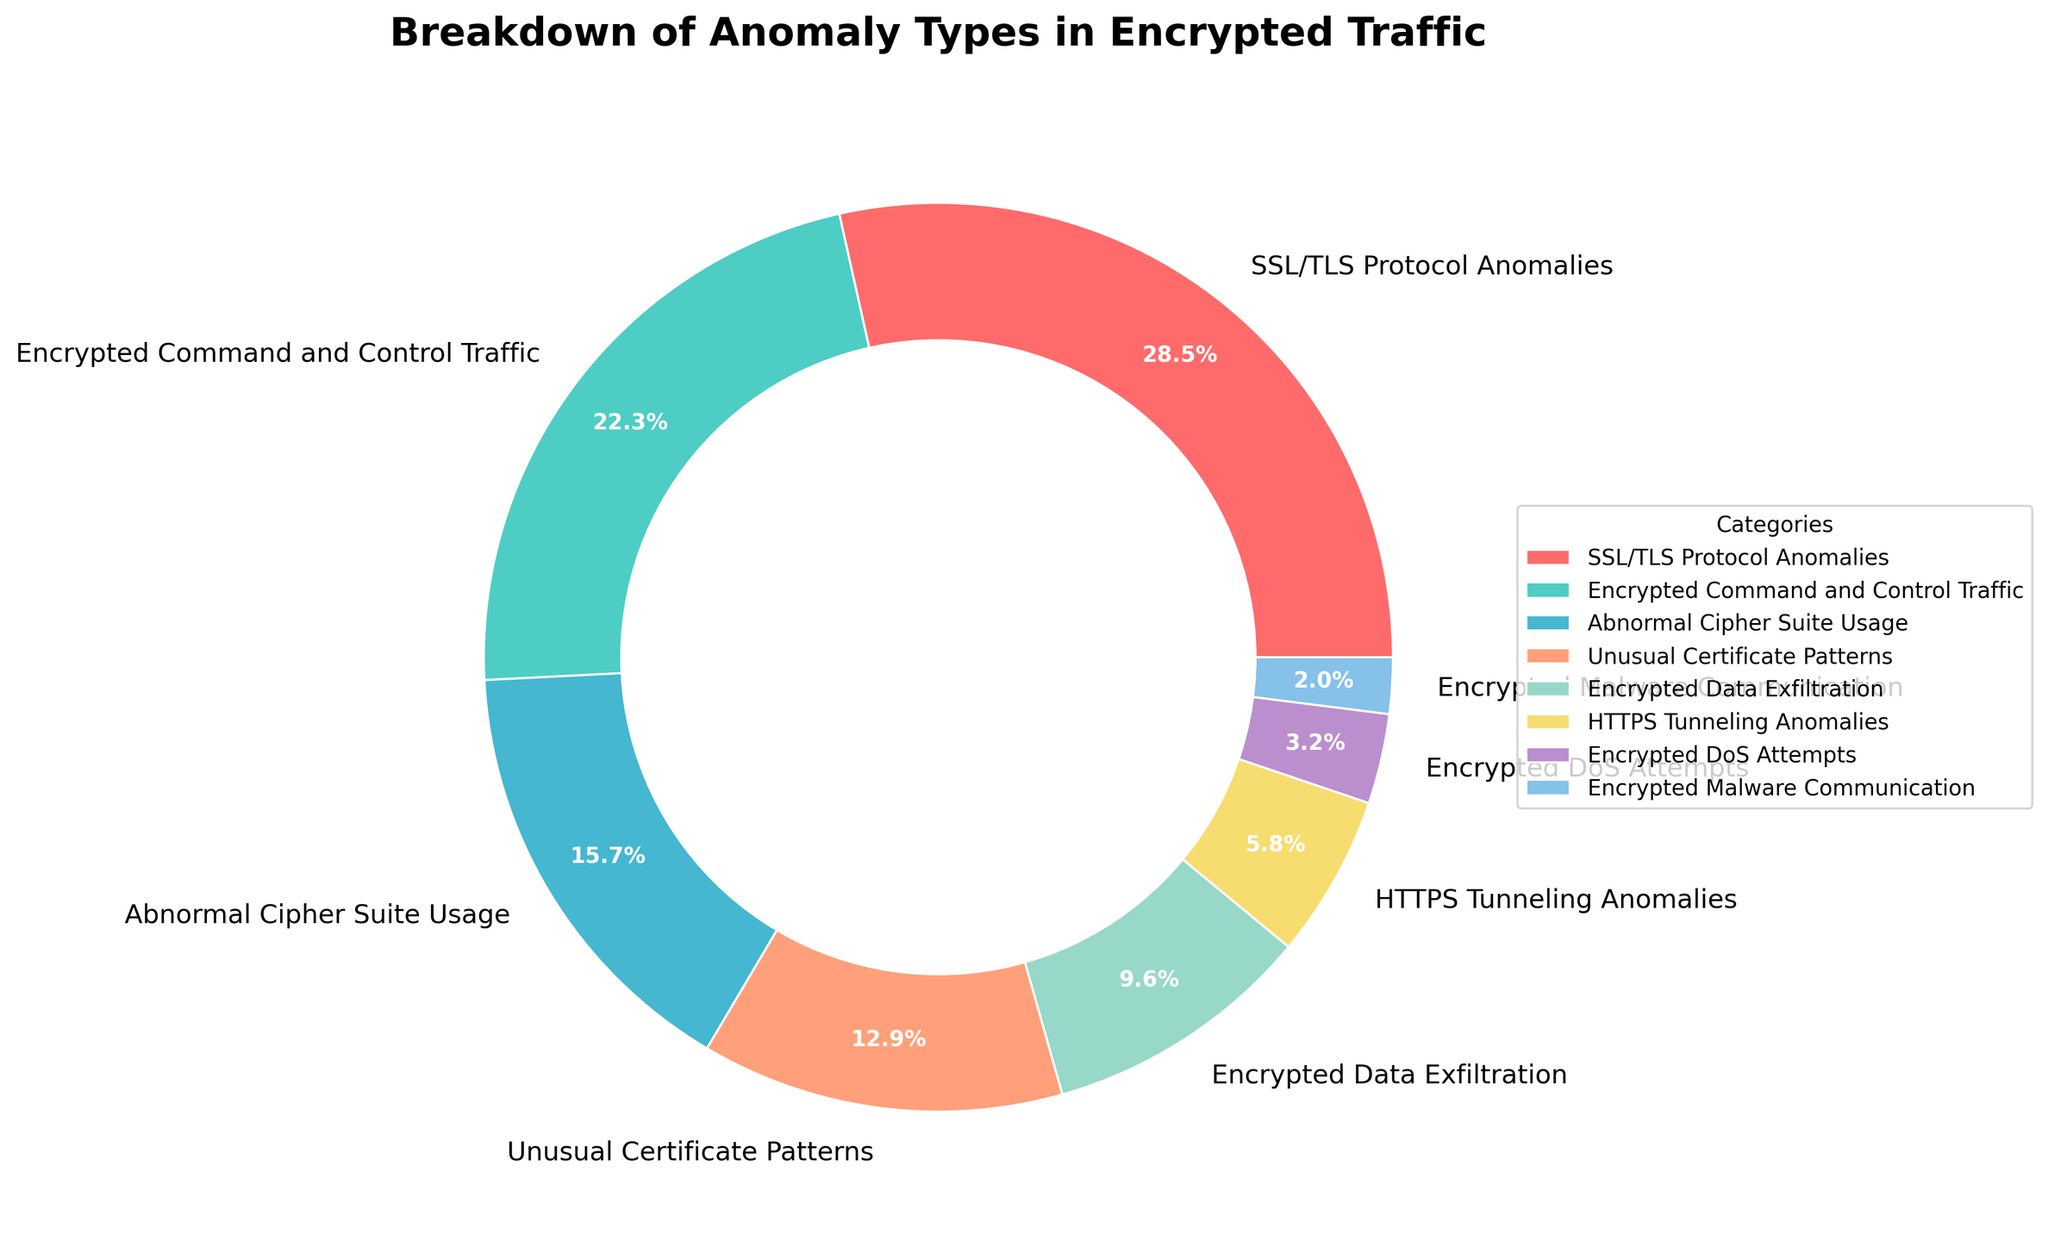What's the most common anomaly type detected in encrypted traffic? According to the pie chart, the "SSL/TLS Protocol Anomalies" is the largest segment, occupying 28.5% of the total.
Answer: SSL/TLS Protocol Anomalies Which anomaly type represents the smallest portion of detected traffic? The smallest segment in the pie chart is "Encrypted Malware Communication," which accounts for 2.0% of the total.
Answer: Encrypted Malware Communication How much larger (in percentage points) is the "SSL/TLS Protocol Anomalies" segment compared to the "Encrypted Command and Control Traffic" segment? The "SSL/TLS Protocol Anomalies" segment is 28.5%, and the "Encrypted Command and Control Traffic" segment is 22.3%. The difference is 28.5% - 22.3% = 6.2 percentage points.
Answer: 6.2 percentage points What is the combined percentage of "Encrypted Data Exfiltration" and "HTTPS Tunneling Anomalies"? "Encrypted Data Exfiltration" is 9.6%, and "HTTPS Tunneling Anomalies" is 5.8%. Adding these gives 9.6% + 5.8% = 15.4%.
Answer: 15.4% Which two anomaly types together constitute exactly half of the total detected anomalies? Adding "SSL/TLS Protocol Anomalies" (28.5%) and "Encrypted Command and Control Traffic" (22.3%) gives 28.5% + 22.3% = 50.8%, which is the closest to half without exceeding.
Answer: SSL/TLS Protocol Anomalies and Encrypted Command and Control Traffic How many anomaly types individually cover more than 10% of the detected traffic? Segments that individually cover more than 10% are "SSL/TLS Protocol Anomalies" (28.5%), "Encrypted Command and Control Traffic" (22.3%), "Abnormal Cipher Suite Usage" (15.7%), and "Unusual Certificate Patterns" (12.9%). This makes 4 anomaly types.
Answer: 4 Which segment is represented by a color similar to cyan/turquoise? The "Encrypted Command and Control Traffic" is shown in a turquoise color in the pie chart.
Answer: Encrypted Command and Control Traffic What proportion of the total does the "Unusual Certificate Patterns" category represent relative to "Abnormal Cipher Suite Usage"? "Unusual Certificate Patterns" is 12.9%, and "Abnormal Cipher Suite Usage" is 15.7%. The proportion is 12.9 / 15.7 = 0.82 (or 82%).
Answer: 82% What is the sum of the three smallest detected anomaly types in terms of percentage? The three smallest segments are "Encrypted DoS Attempts" (3.2%), "Encrypted Malware Communication" (2.0%), and "HTTPS Tunneling Anomalies" (5.8%). The sum is 3.2% + 2.0% + 5.8% = 11.0%.
Answer: 11.0% How many anomaly types have been detected that involve command and control traffic or malware communication? The pie chart indicates two types related to this: "Encrypted Command and Control Traffic" and "Encrypted Malware Communication."
Answer: 2 